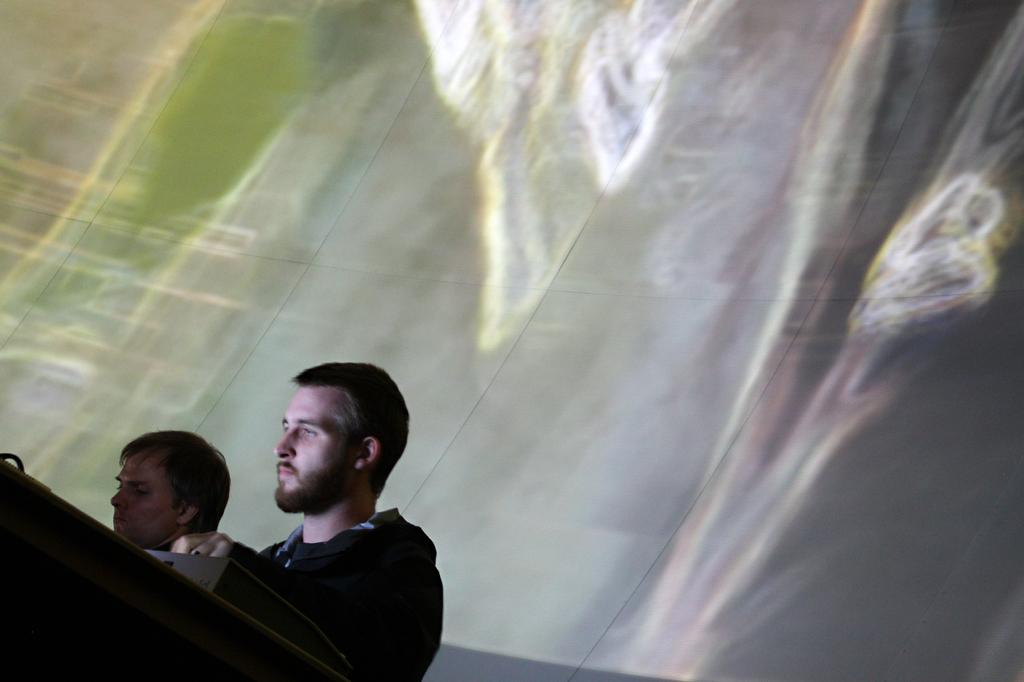How many people are present in the image? There are two people in the image. What else can be seen in the image besides the people? There are other objects in the image. What is visible in the background of the image? There is a wall in the background of the image. What type of notebook is the tramp using to write in the image? There is no tramp or notebook present in the image. How many bikes are visible in the image? There are no bikes visible in the image. 